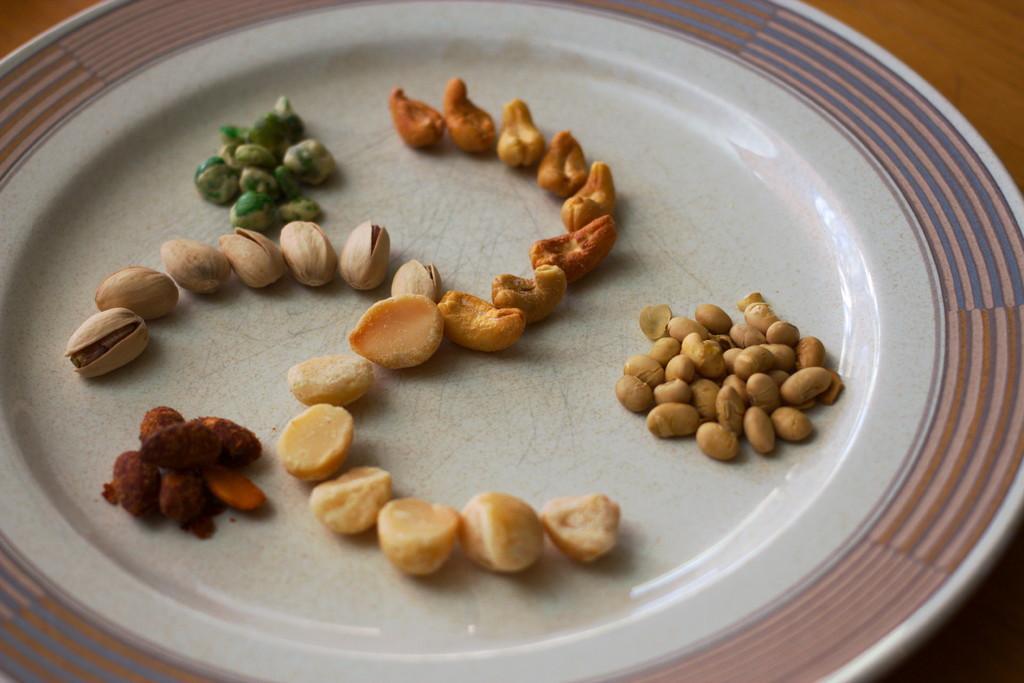Can you describe this image briefly? In this image, I can see dry fruits on a plate, which is kept on an object. 